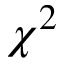Convert formula to latex. <formula><loc_0><loc_0><loc_500><loc_500>\chi ^ { 2 }</formula> 